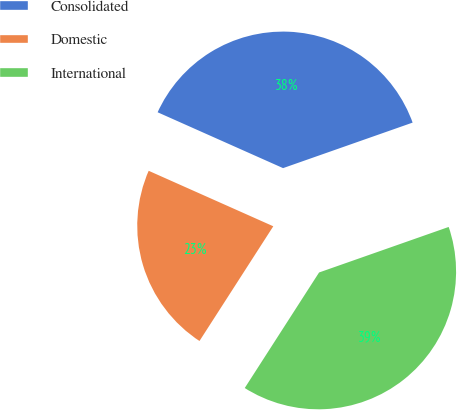<chart> <loc_0><loc_0><loc_500><loc_500><pie_chart><fcel>Consolidated<fcel>Domestic<fcel>International<nl><fcel>37.96%<fcel>22.57%<fcel>39.48%<nl></chart> 